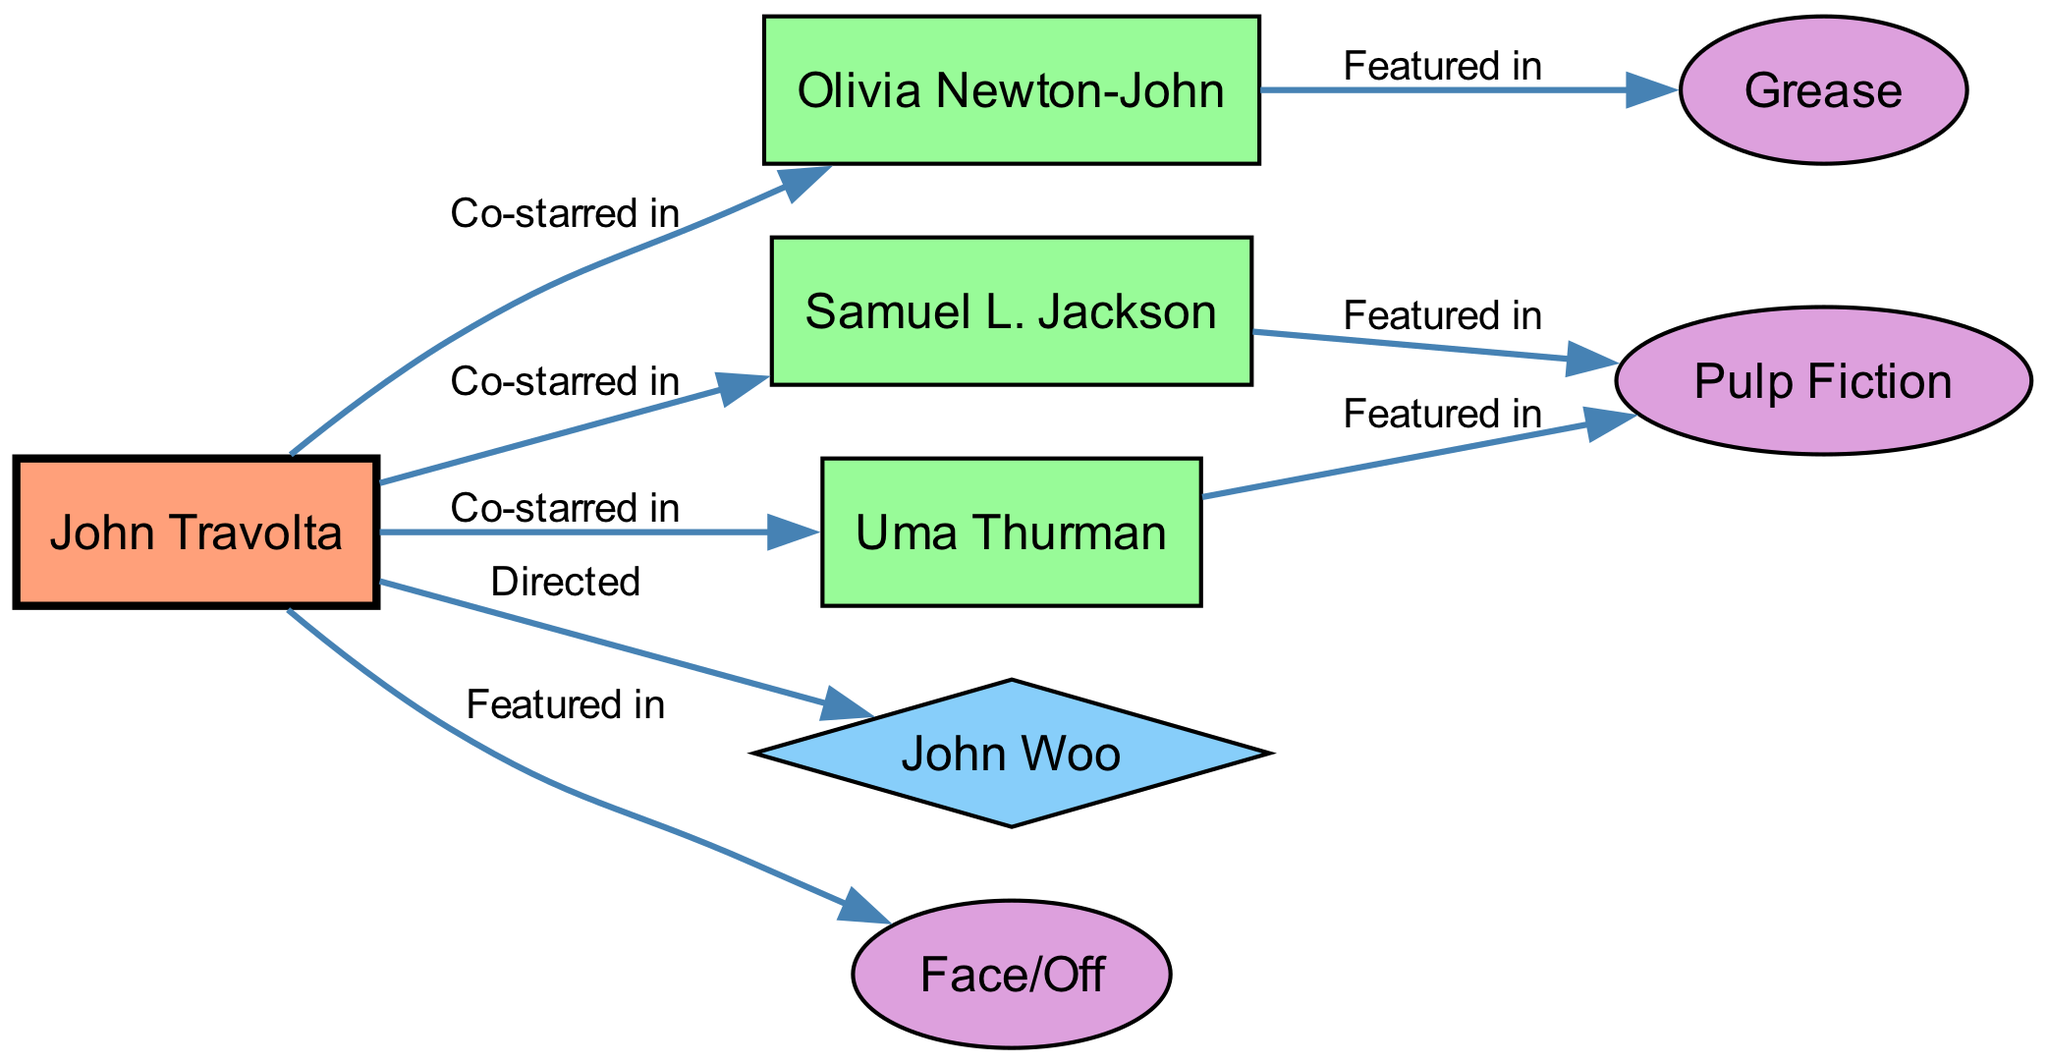What is the total number of nodes in the diagram? Count the nodes listed in the data section, separating them by their types. The nodes are: John Travolta, Olivia Newton-John, Samuel L. Jackson, Uma Thurman, John Woo, Grease, Pulp Fiction, and Face/Off. There are 8 nodes in total.
Answer: 8 Who directed John Travolta in any film? Trace the edges from John Travolta to identify the directed relationships. The directed edge connects John Travolta to John Woo, indicating John Woo directed John Travolta.
Answer: John Woo In which film did John Travolta co-star with Samuel L. Jackson? Look for the directed edge that connects John Travolta to Samuel L. Jackson, and then identify the film associated with Samuel L. Jackson. The edge indicates that they both co-starred in Pulp Fiction.
Answer: Pulp Fiction How many films feature John Travolta? Count the number of edges that connect John Travolta to film nodes. The edge connections are: Face/Off and co-star connections leading to films. Thus, John Travolta is featured in 2 films according to the connections.
Answer: 2 Which actor co-starred with John Travolta in both 'Grease' and 'Pulp Fiction'? Analyze the edges for co-stars connected to John Travolta and identify any overlaps in featured films. Olivia Newton-John co-starred in Grease, while both Samuel L. Jackson and Uma Thurman co-starred in Pulp Fiction. No co-star appears in both films, indicating a rejection of this assumption. Therefore, no actor fits the criteria.
Answer: None What is the relationship between John Travolta and Uma Thurman? Examine the edges originating from John Travolta to find any connections with Uma Thurman. There is an edge that indicates that John Travolta co-starred with Uma Thurman.
Answer: Co-starred in Name a film that features both John Travolta and Olivia Newton-John. Look for a directed edge that indicates a connection. The directed edge shows that Olivia Newton-John co-starred with John Travolta in Grease, which is a featured film.
Answer: Grease How many co-stars of John Travolta have worked in films with him? Identify the edges connecting John Travolta to other co-stars and then count those edges to determine how many co-stars have collaborated in film projects with him. John Travolta has three distinct co-stars listed, showing clear collaborations in films.
Answer: 3 What color represents directors in the diagram? Check the node style definitions to find the color associated with directors. The code specifies that directors are represented in blue, indicated by the hexadecimal color code #87CEFA.
Answer: Blue 